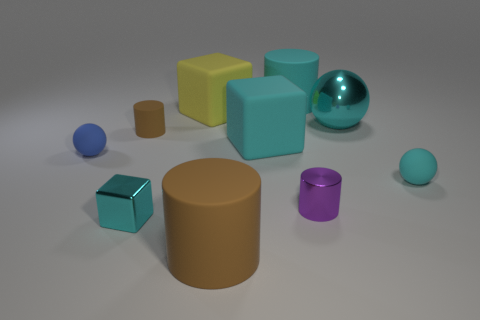How many other things are the same size as the cyan cylinder?
Keep it short and to the point. 4. Are there more brown rubber objects that are left of the tiny cyan block than yellow things?
Provide a succinct answer. No. Are there any other big spheres that have the same color as the large sphere?
Provide a short and direct response. No. What color is the shiny cylinder that is the same size as the blue sphere?
Provide a succinct answer. Purple. Are there any small metal cubes in front of the small thing in front of the purple cylinder?
Your answer should be very brief. No. What is the material of the sphere left of the tiny brown rubber cylinder?
Your response must be concise. Rubber. Is the material of the large cylinder in front of the tiny brown object the same as the tiny ball that is behind the small cyan ball?
Offer a very short reply. Yes. Are there the same number of tiny metallic things that are to the left of the large cyan block and metallic cubes left of the tiny blue matte sphere?
Offer a very short reply. No. What number of balls have the same material as the big yellow block?
Offer a terse response. 2. There is a small rubber object that is the same color as the small cube; what shape is it?
Give a very brief answer. Sphere. 